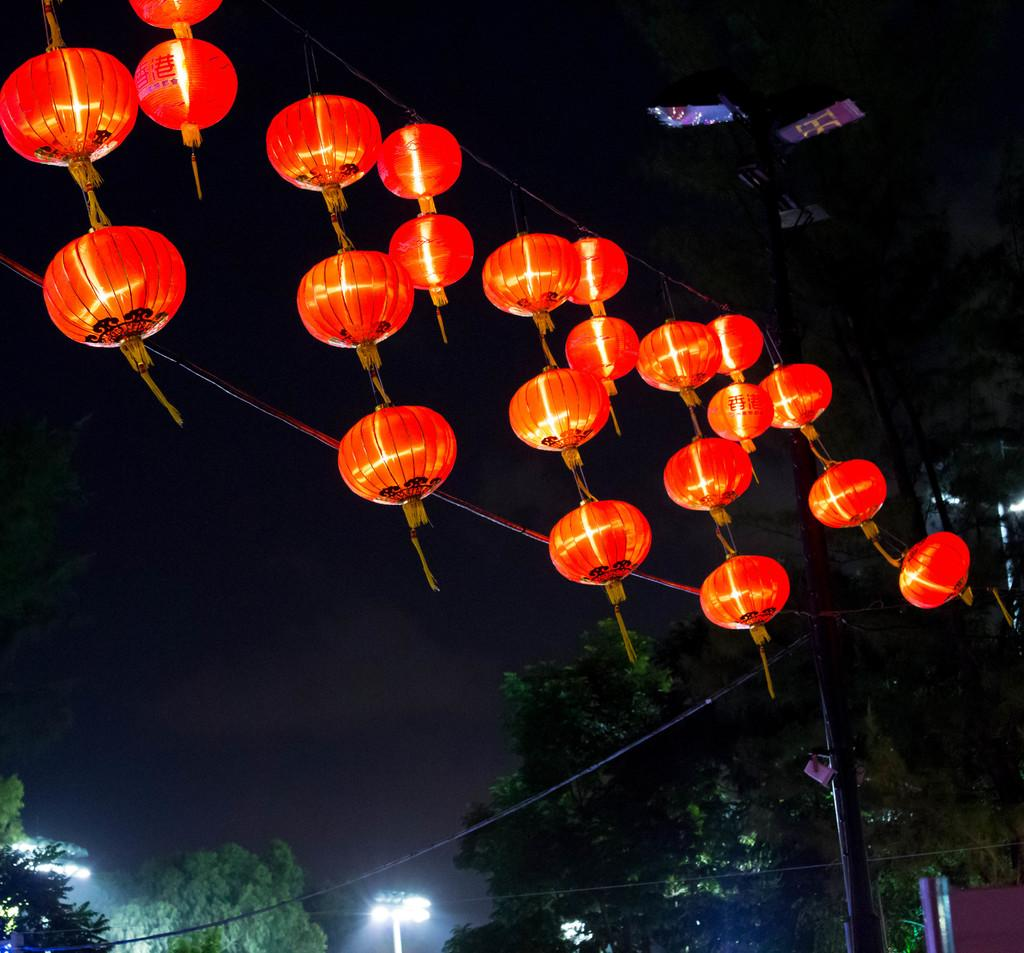What type of lights are present in the image? There are decorative globe lights in the image. What color are the lights? The lights are in orange color. What else can be seen in the image besides the lights? There are wires visible in the image. What can be seen in the background of the image? There are trees and flood lights in the background of the image. Can you see any knots in the wires in the image? There is no mention of knots in the wires in the image, so we cannot determine if any are present. 